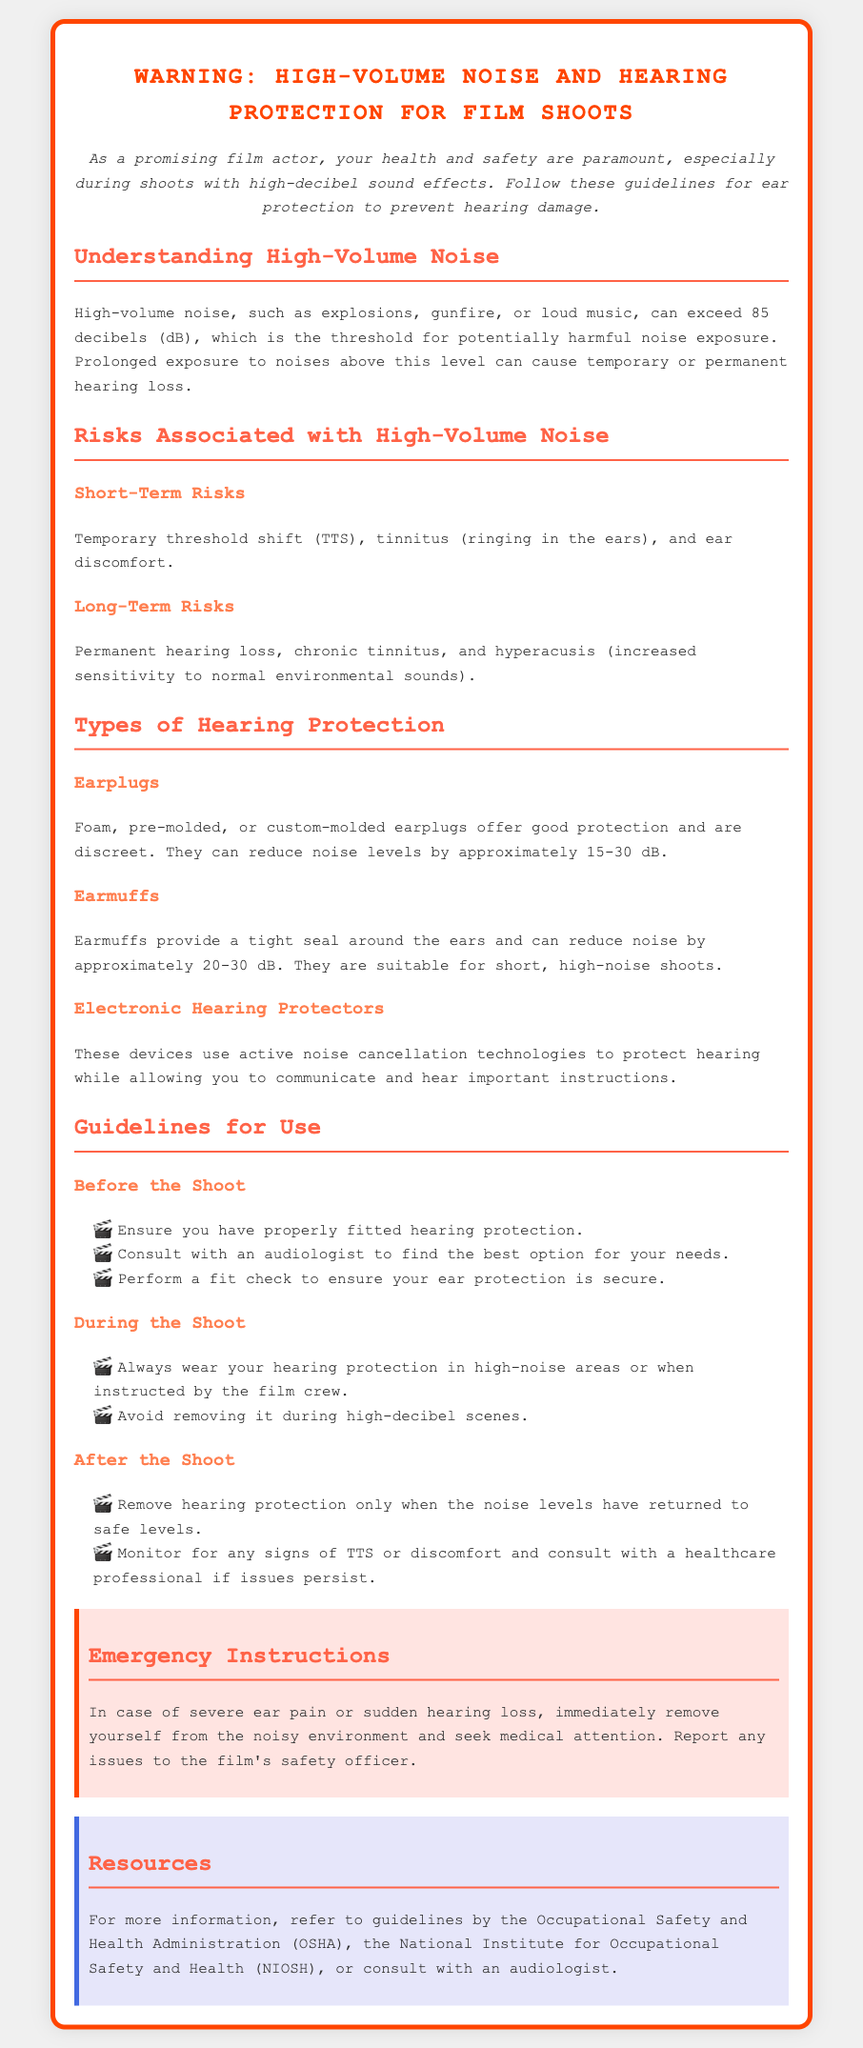What is the threshold for potentially harmful noise exposure? The threshold for potentially harmful noise exposure is 85 decibels (dB).
Answer: 85 decibels What types of hearing protection are mentioned? The document lists earplugs, earmuffs, and electronic hearing protectors as types of hearing protection.
Answer: Earplugs, earmuffs, electronic hearing protectors What should you do before the shoot? Before the shoot, you should ensure you have properly fitted hearing protection and consult with an audiologist.
Answer: Ensure fitted protection; consult an audiologist What should you avoid during high-decibel scenes? You should avoid removing your hearing protection during high-decibel scenes.
Answer: Avoid removing ear protection What should you monitor for after the shoot? After the shoot, you should monitor for any signs of temporary threshold shift (TTS) or discomfort.
Answer: Signs of TTS or discomfort What should you do in case of severe ear pain? In case of severe ear pain, you should remove yourself from the noisy environment and seek medical attention.
Answer: Seek medical attention How much noise reduction do earmuffs provide? Earmuffs can reduce noise by approximately 20-30 dB.
Answer: 20-30 dB What are the short-term risks mentioned? Short-term risks include temporary threshold shift, tinnitus, and ear discomfort.
Answer: TTS, tinnitus, ear discomfort How many guidelines are provided for 'During the Shoot'? There are two guidelines provided for 'During the Shoot'.
Answer: Two guidelines 